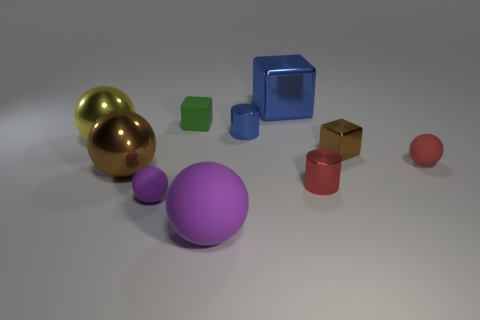Is there a small sphere of the same color as the large rubber sphere?
Make the answer very short. Yes. What number of metallic things are green cubes or big cubes?
Make the answer very short. 1. What number of tiny matte spheres are behind the shiny cylinder that is behind the red metal object?
Offer a very short reply. 0. What number of tiny blue things have the same material as the green block?
Offer a very short reply. 0. How many tiny objects are green rubber blocks or purple matte balls?
Provide a short and direct response. 2. What is the shape of the rubber thing that is both to the left of the big purple matte thing and in front of the small brown metallic cube?
Provide a succinct answer. Sphere. Is the material of the small blue thing the same as the small brown cube?
Keep it short and to the point. Yes. There is a metallic block that is the same size as the red rubber ball; what color is it?
Offer a very short reply. Brown. The large object that is in front of the small red rubber ball and behind the tiny purple matte ball is what color?
Provide a succinct answer. Brown. The metal object that is the same color as the small metallic block is what size?
Your answer should be compact. Large. 